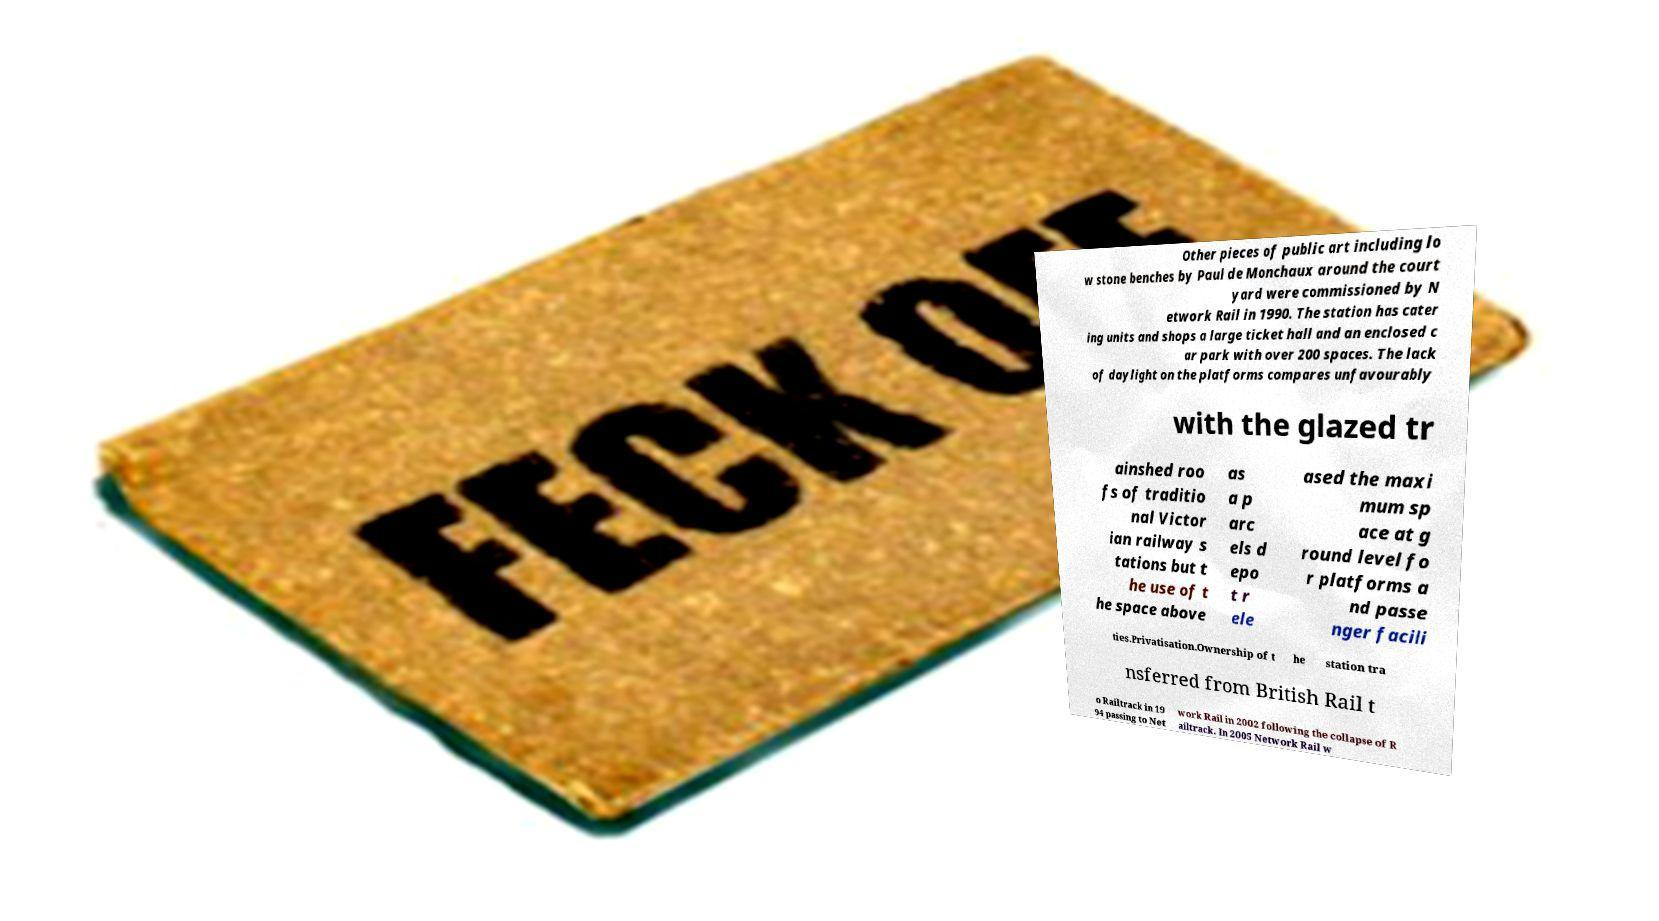What messages or text are displayed in this image? I need them in a readable, typed format. Other pieces of public art including lo w stone benches by Paul de Monchaux around the court yard were commissioned by N etwork Rail in 1990. The station has cater ing units and shops a large ticket hall and an enclosed c ar park with over 200 spaces. The lack of daylight on the platforms compares unfavourably with the glazed tr ainshed roo fs of traditio nal Victor ian railway s tations but t he use of t he space above as a p arc els d epo t r ele ased the maxi mum sp ace at g round level fo r platforms a nd passe nger facili ties.Privatisation.Ownership of t he station tra nsferred from British Rail t o Railtrack in 19 94 passing to Net work Rail in 2002 following the collapse of R ailtrack. In 2005 Network Rail w 